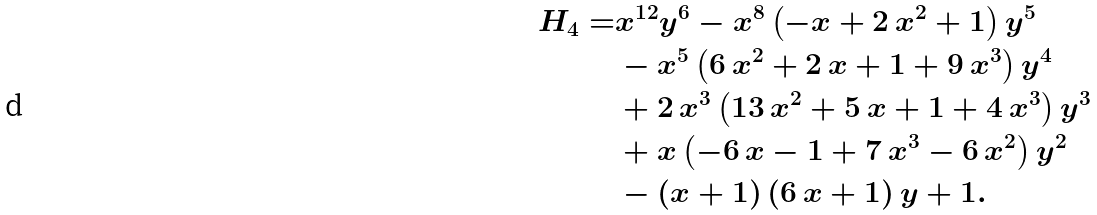<formula> <loc_0><loc_0><loc_500><loc_500>H _ { 4 } = & { x } ^ { 1 2 } { y } ^ { 6 } - { x } ^ { 8 } \left ( - x + 2 \, { x } ^ { 2 } + 1 \right ) { y } ^ { 5 } \\ & - { x } ^ { 5 } \left ( 6 \, { x } ^ { 2 } + 2 \, x + 1 + 9 \, { x } ^ { 3 } \right ) { y } ^ { 4 } \\ & + 2 \, { x } ^ { 3 } \left ( 1 3 \, { x } ^ { 2 } + 5 \, x + 1 + 4 \, { x } ^ { 3 } \right ) { y } ^ { 3 } \\ & + x \left ( - 6 \, x - 1 + 7 \, { x } ^ { 3 } - 6 \, { x } ^ { 2 } \right ) { y } ^ { 2 } \\ & - \left ( x + 1 \right ) \left ( 6 \, x + 1 \right ) y + 1 .</formula> 